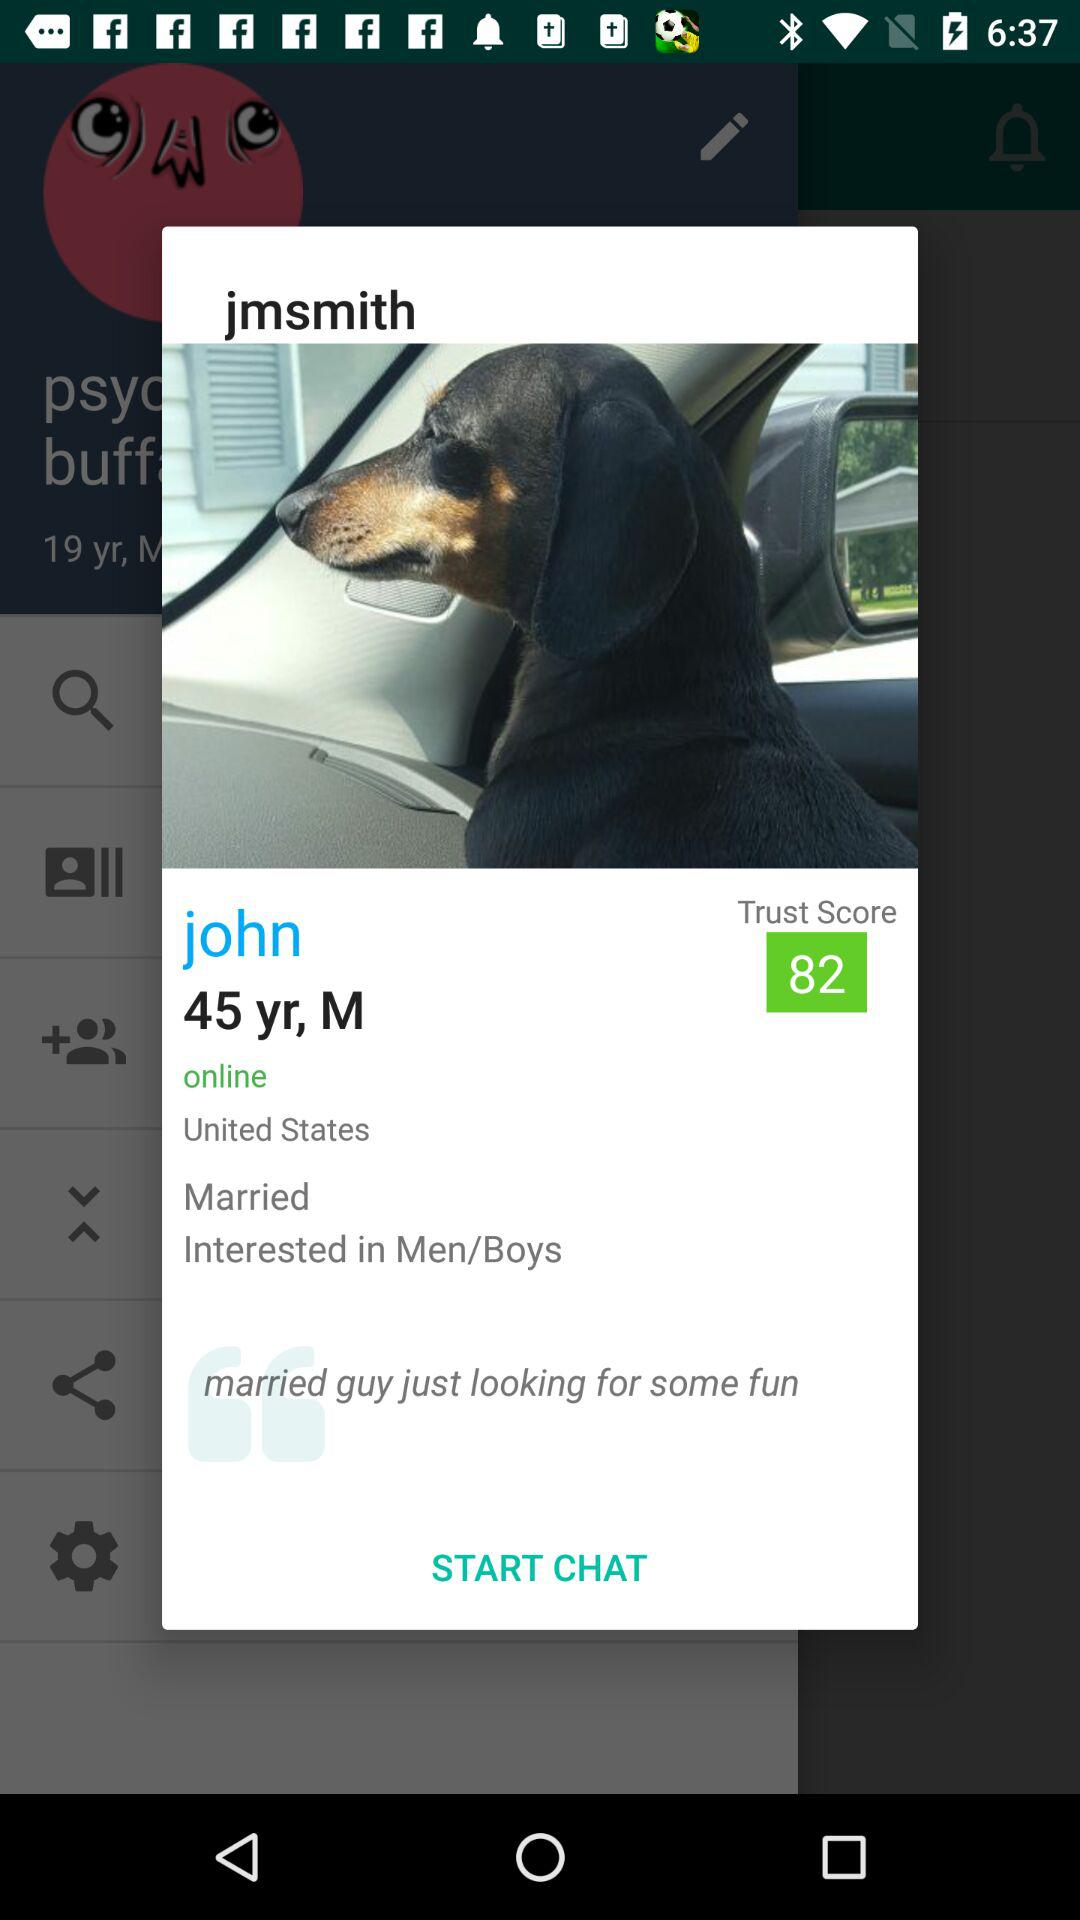What is the trust score? The trust score is 82. 